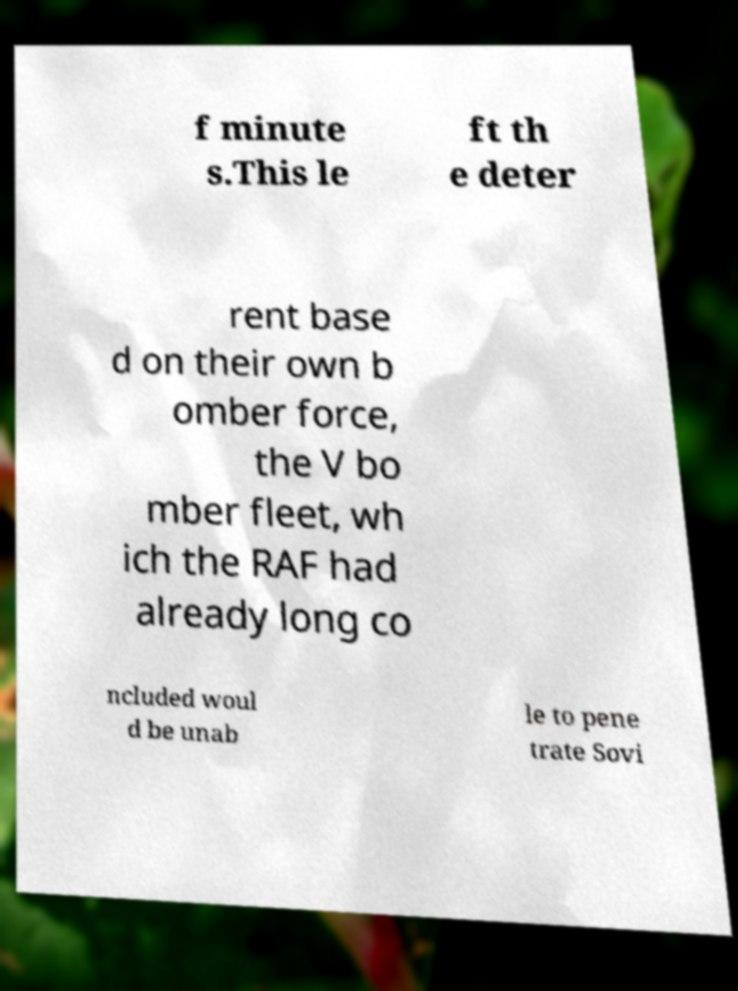Please read and relay the text visible in this image. What does it say? f minute s.This le ft th e deter rent base d on their own b omber force, the V bo mber fleet, wh ich the RAF had already long co ncluded woul d be unab le to pene trate Sovi 